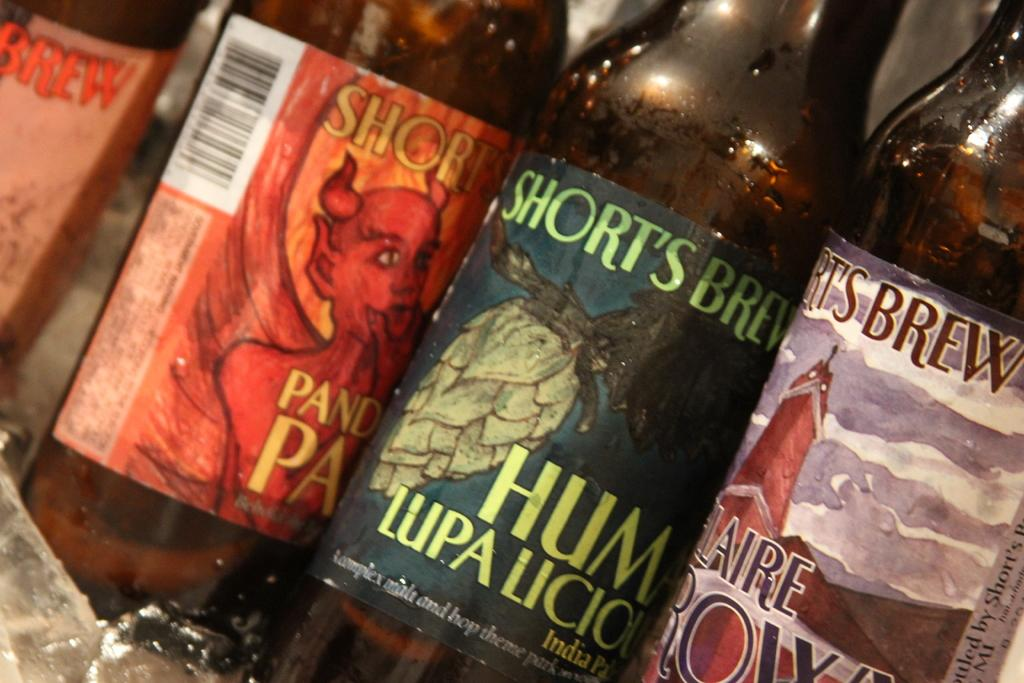How many wine bottles are visible in the image? There are four wine bottles in the image. Where are the wine bottles located? The wine bottles are on a platform. Can you describe the appearance of the wine bottles? Each wine bottle has a different sticker on it. What type of cattle can be seen grazing near the wine bottles in the image? There are no cattle present in the image; it only features four wine bottles on a platform. 